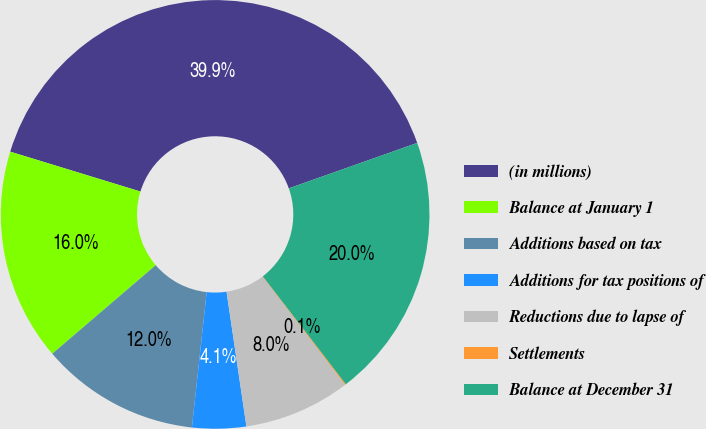Convert chart. <chart><loc_0><loc_0><loc_500><loc_500><pie_chart><fcel>(in millions)<fcel>Balance at January 1<fcel>Additions based on tax<fcel>Additions for tax positions of<fcel>Reductions due to lapse of<fcel>Settlements<fcel>Balance at December 31<nl><fcel>39.86%<fcel>15.99%<fcel>12.01%<fcel>4.06%<fcel>8.03%<fcel>0.08%<fcel>19.97%<nl></chart> 